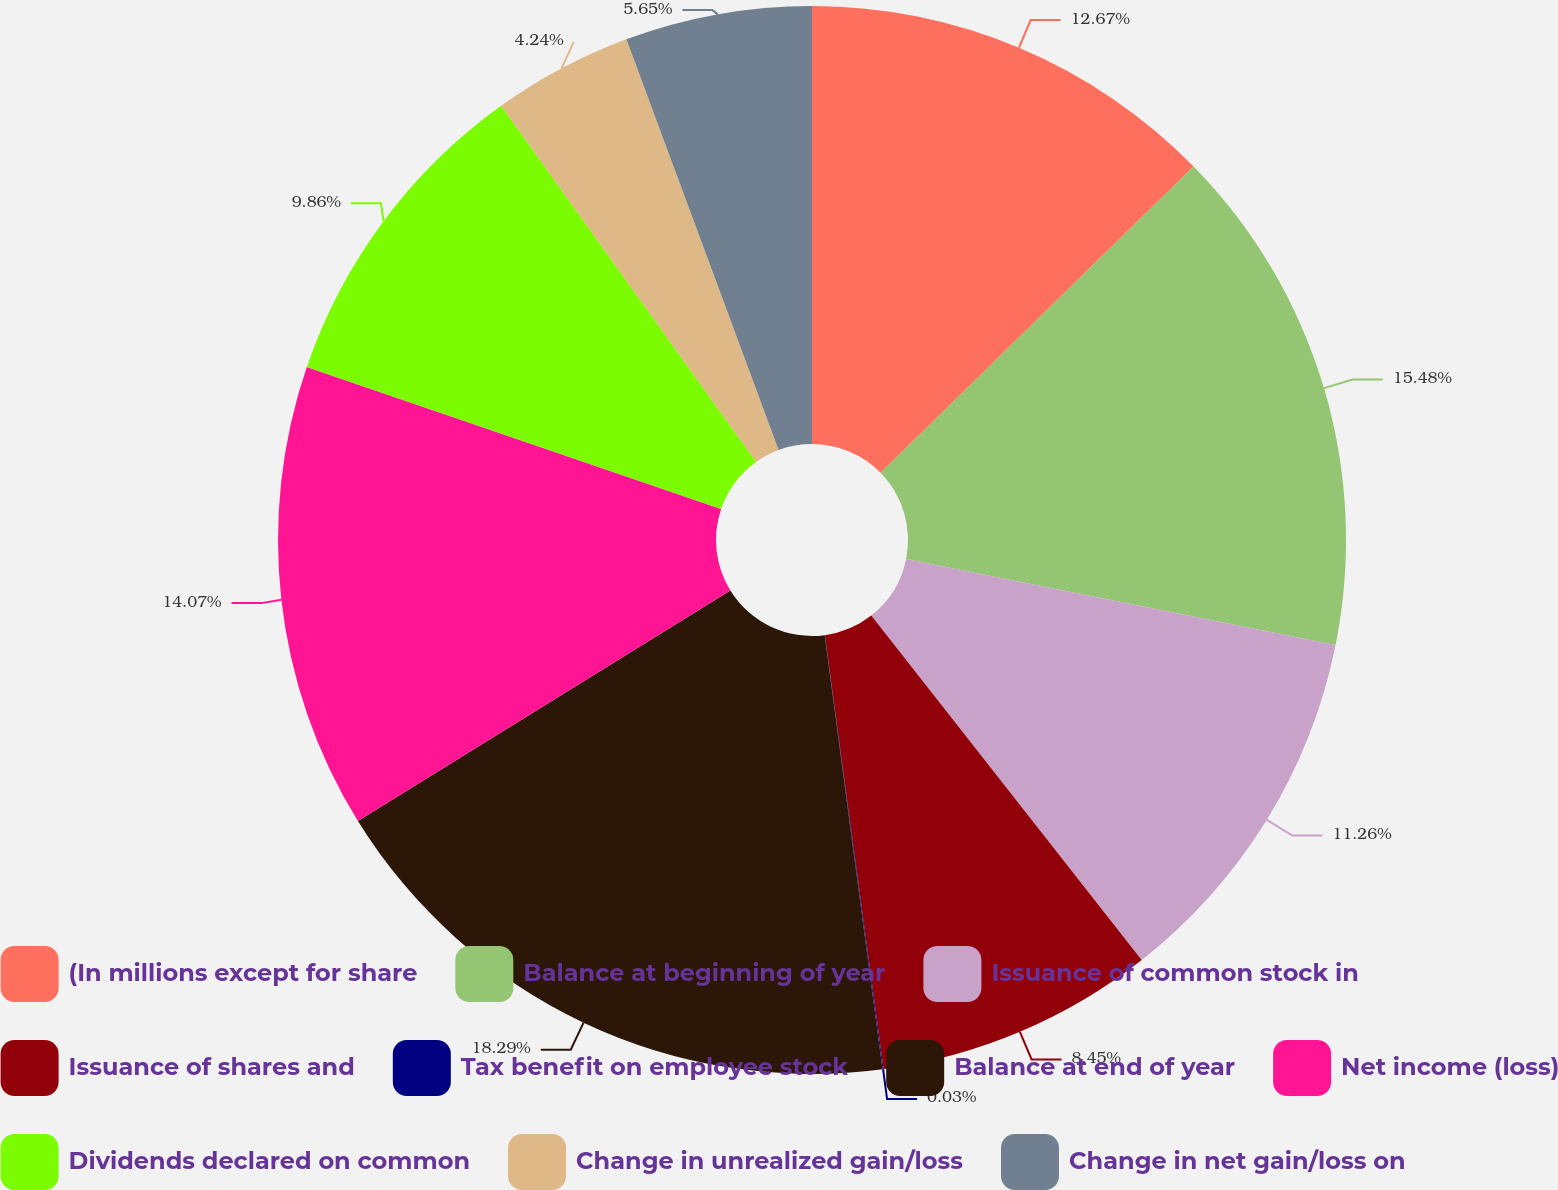<chart> <loc_0><loc_0><loc_500><loc_500><pie_chart><fcel>(In millions except for share<fcel>Balance at beginning of year<fcel>Issuance of common stock in<fcel>Issuance of shares and<fcel>Tax benefit on employee stock<fcel>Balance at end of year<fcel>Net income (loss)<fcel>Dividends declared on common<fcel>Change in unrealized gain/loss<fcel>Change in net gain/loss on<nl><fcel>12.67%<fcel>15.48%<fcel>11.26%<fcel>8.45%<fcel>0.03%<fcel>18.29%<fcel>14.07%<fcel>9.86%<fcel>4.24%<fcel>5.65%<nl></chart> 